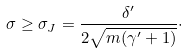Convert formula to latex. <formula><loc_0><loc_0><loc_500><loc_500>\sigma \geq \sigma _ { J } = \frac { \delta ^ { \prime } } { 2 \sqrt { m ( \gamma ^ { \prime } + 1 ) } } \cdot</formula> 